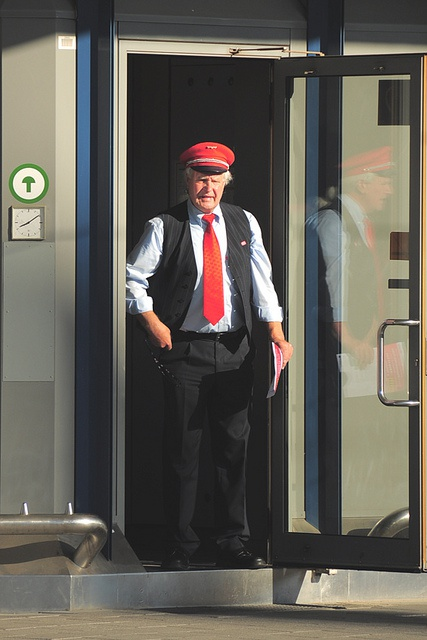Describe the objects in this image and their specific colors. I can see people in black, gray, white, and salmon tones, tie in black, salmon, red, brown, and gray tones, and clock in black, beige, gray, and darkgray tones in this image. 